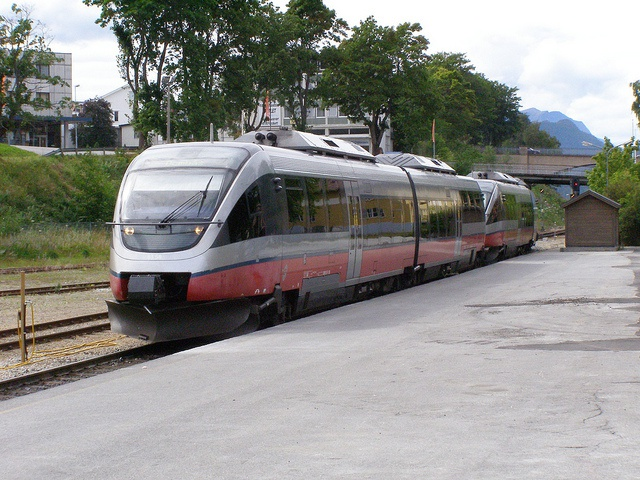Describe the objects in this image and their specific colors. I can see train in white, black, gray, lightgray, and darkgray tones and traffic light in white, black, navy, maroon, and darkblue tones in this image. 